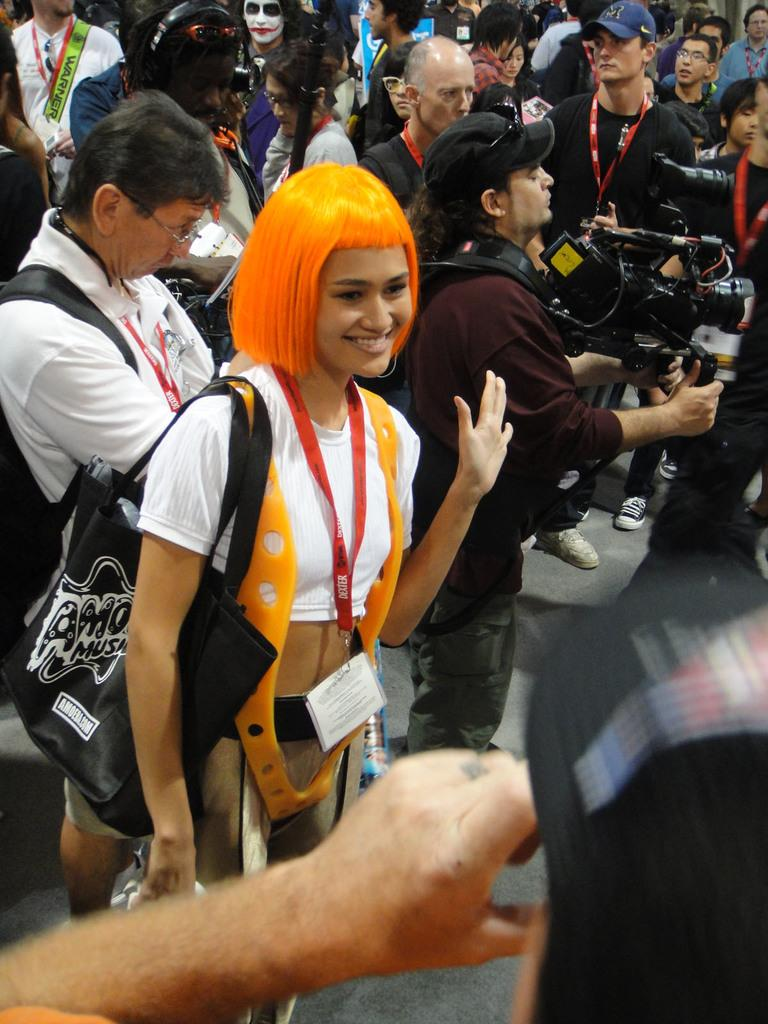How many people are visible in the image? There are many people in the image. Can you describe the person on the right side of the image? The person on the right side is holding a video camera. What type of scissors are being used to make a decision in the image? There are no scissors or decisions being made in the image; it features many people and a person holding a video camera. Can you tell me where the cemetery is located in the image? There is no cemetery present in the image. 